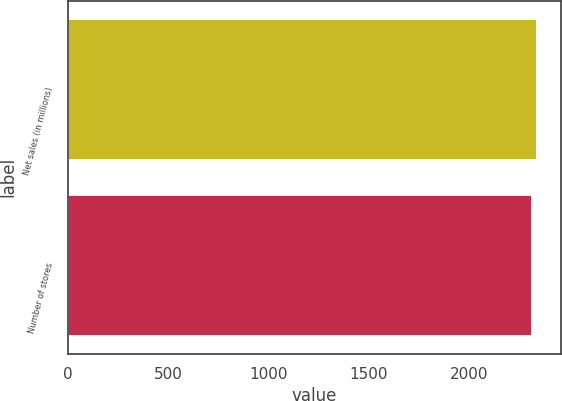Convert chart to OTSL. <chart><loc_0><loc_0><loc_500><loc_500><bar_chart><fcel>Net sales (in millions)<fcel>Number of stores<nl><fcel>2340.4<fcel>2311<nl></chart> 